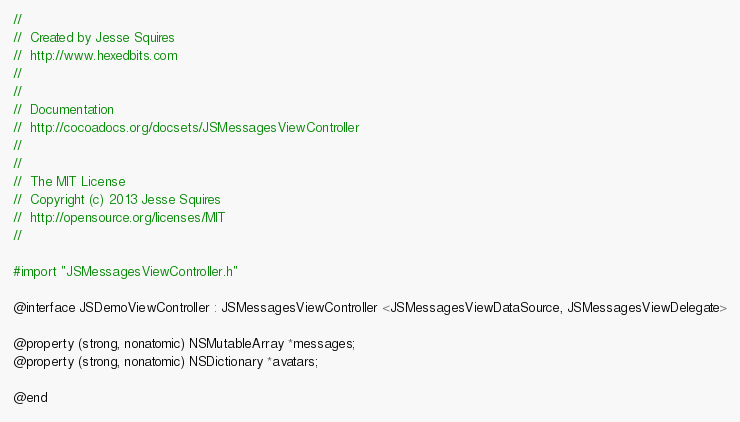Convert code to text. <code><loc_0><loc_0><loc_500><loc_500><_C_>//
//  Created by Jesse Squires
//  http://www.hexedbits.com
//
//
//  Documentation
//  http://cocoadocs.org/docsets/JSMessagesViewController
//
//
//  The MIT License
//  Copyright (c) 2013 Jesse Squires
//  http://opensource.org/licenses/MIT
//

#import "JSMessagesViewController.h"

@interface JSDemoViewController : JSMessagesViewController <JSMessagesViewDataSource, JSMessagesViewDelegate>

@property (strong, nonatomic) NSMutableArray *messages;
@property (strong, nonatomic) NSDictionary *avatars;

@end
</code> 